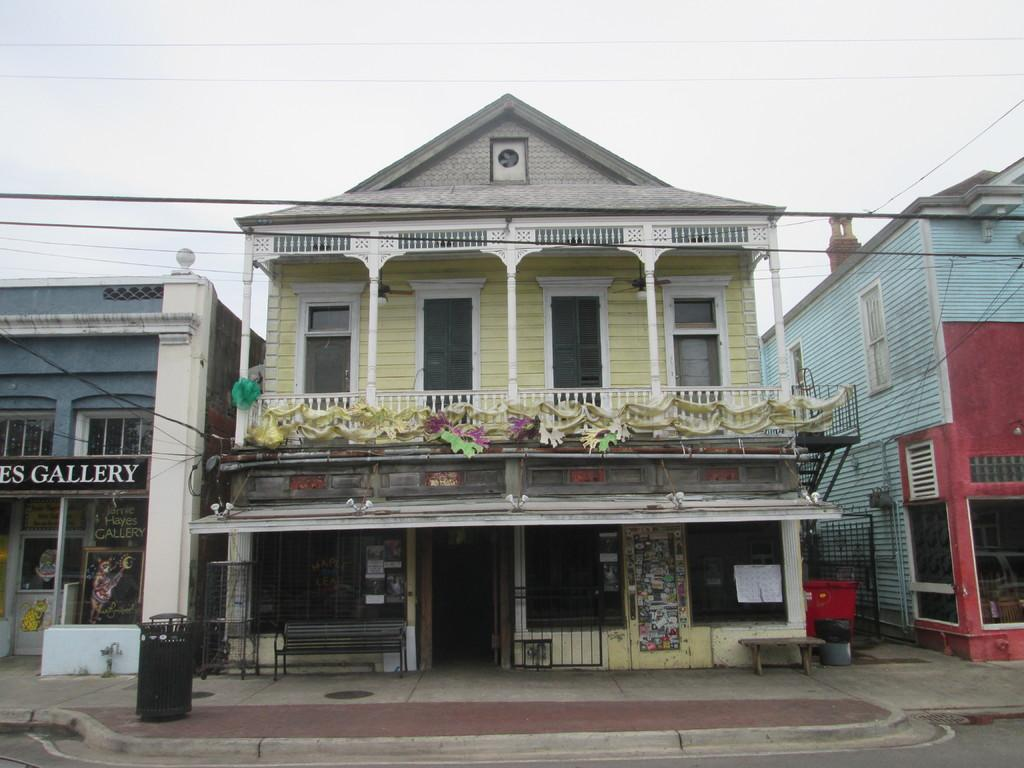What type of structures can be seen in the image? There are buildings in the image. What is located in front of the buildings? There is a footpath in front of the building. Are there any seating areas in the image? Yes, there are benches in the image. What type of magic is being performed near the seashore in the image? There is no mention of magic or a seashore in the image; it features buildings, a footpath, and benches. 